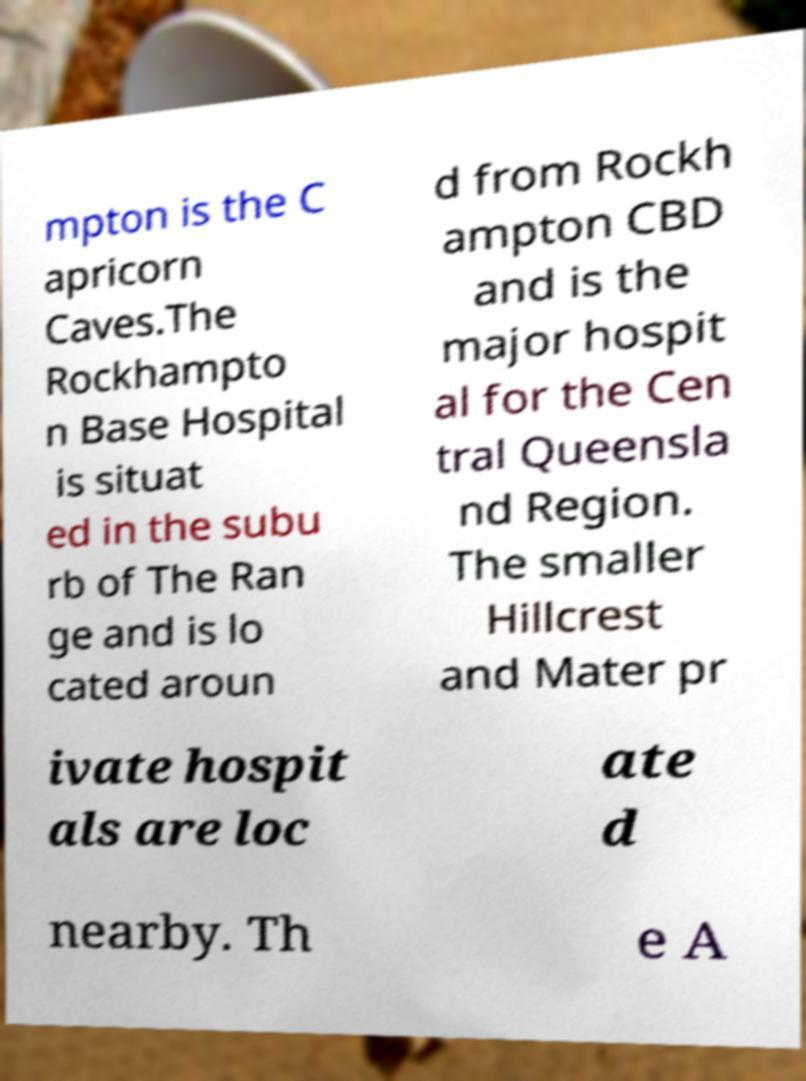Could you extract and type out the text from this image? mpton is the C apricorn Caves.The Rockhampto n Base Hospital is situat ed in the subu rb of The Ran ge and is lo cated aroun d from Rockh ampton CBD and is the major hospit al for the Cen tral Queensla nd Region. The smaller Hillcrest and Mater pr ivate hospit als are loc ate d nearby. Th e A 